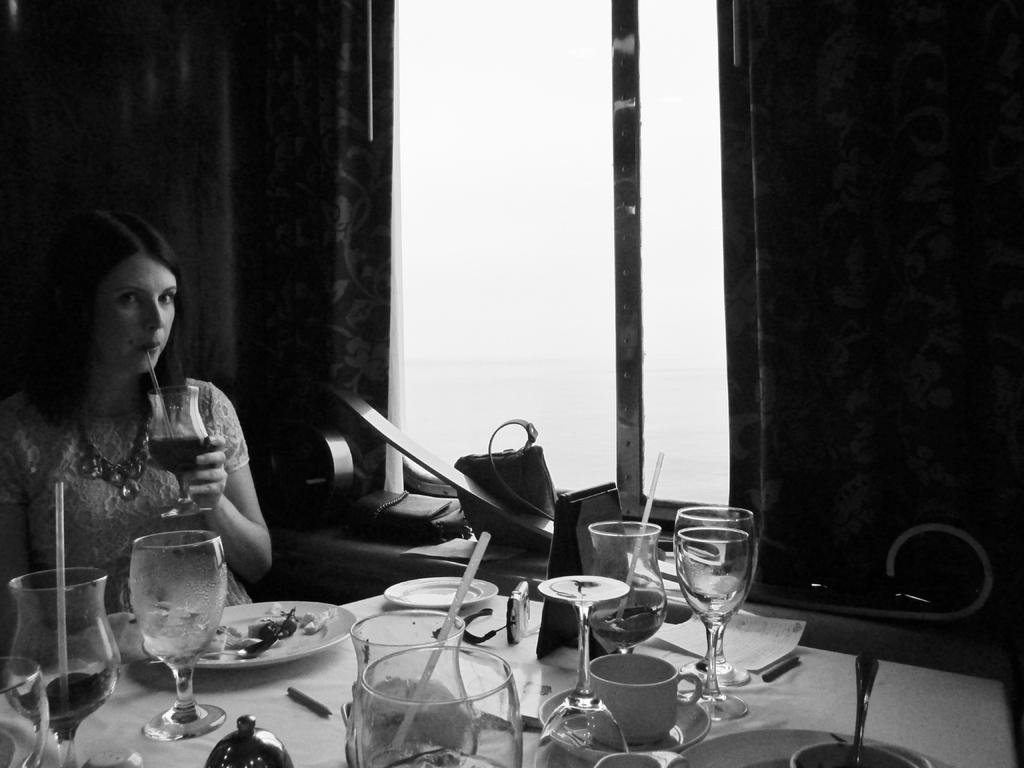How would you summarize this image in a sentence or two? In this image there is a woman sitting near a table , there are glass, plate,food, straw, bag, card, cup, saucer, paper, pen and in back ground there is window, curtain. 